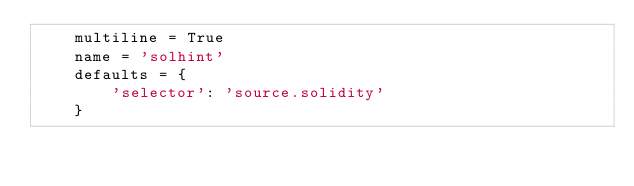Convert code to text. <code><loc_0><loc_0><loc_500><loc_500><_Python_>    multiline = True
    name = 'solhint'
    defaults = {
        'selector': 'source.solidity'
    }
</code> 